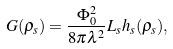Convert formula to latex. <formula><loc_0><loc_0><loc_500><loc_500>G ( \rho _ { s } ) = \frac { \Phi _ { 0 } ^ { 2 } } { 8 \pi \lambda ^ { 2 } } L _ { s } h _ { s } ( \rho _ { s } ) ,</formula> 